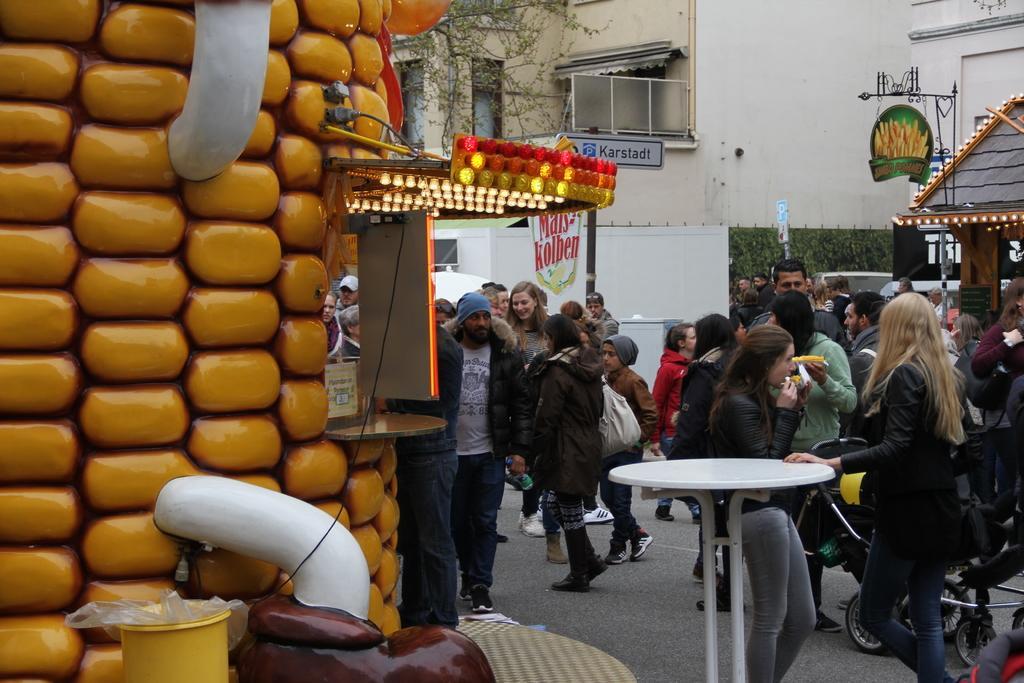In one or two sentences, can you explain what this image depicts? In this picture there are some people standing on the road. There is a table here. In the background there is a wall and some plants here. We can observe a tree here. 